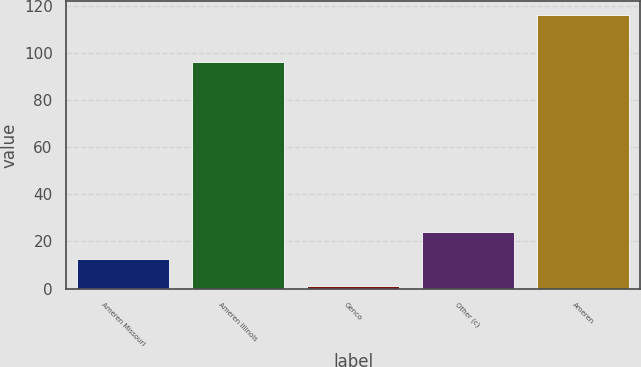<chart> <loc_0><loc_0><loc_500><loc_500><bar_chart><fcel>Ameren Missouri<fcel>Ameren Illinois<fcel>Genco<fcel>Other (c)<fcel>Ameren<nl><fcel>12.5<fcel>96<fcel>1<fcel>24<fcel>116<nl></chart> 